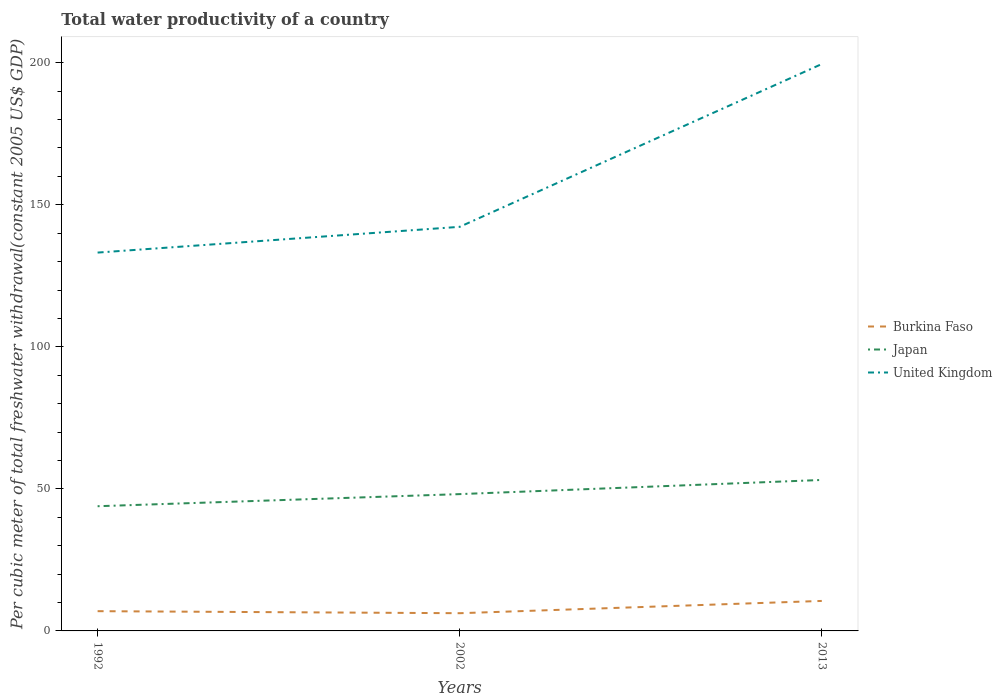Does the line corresponding to United Kingdom intersect with the line corresponding to Burkina Faso?
Give a very brief answer. No. Is the number of lines equal to the number of legend labels?
Your response must be concise. Yes. Across all years, what is the maximum total water productivity in Burkina Faso?
Keep it short and to the point. 6.24. In which year was the total water productivity in United Kingdom maximum?
Your answer should be compact. 1992. What is the total total water productivity in Burkina Faso in the graph?
Provide a short and direct response. -3.6. What is the difference between the highest and the second highest total water productivity in United Kingdom?
Your response must be concise. 66.37. What is the difference between the highest and the lowest total water productivity in Japan?
Offer a terse response. 1. Is the total water productivity in Burkina Faso strictly greater than the total water productivity in United Kingdom over the years?
Your response must be concise. Yes. How many lines are there?
Make the answer very short. 3. Does the graph contain grids?
Offer a very short reply. No. How many legend labels are there?
Your answer should be very brief. 3. What is the title of the graph?
Offer a very short reply. Total water productivity of a country. What is the label or title of the Y-axis?
Keep it short and to the point. Per cubic meter of total freshwater withdrawal(constant 2005 US$ GDP). What is the Per cubic meter of total freshwater withdrawal(constant 2005 US$ GDP) in Burkina Faso in 1992?
Give a very brief answer. 6.95. What is the Per cubic meter of total freshwater withdrawal(constant 2005 US$ GDP) of Japan in 1992?
Your answer should be compact. 43.89. What is the Per cubic meter of total freshwater withdrawal(constant 2005 US$ GDP) in United Kingdom in 1992?
Ensure brevity in your answer.  133.18. What is the Per cubic meter of total freshwater withdrawal(constant 2005 US$ GDP) in Burkina Faso in 2002?
Offer a terse response. 6.24. What is the Per cubic meter of total freshwater withdrawal(constant 2005 US$ GDP) of Japan in 2002?
Offer a very short reply. 48.16. What is the Per cubic meter of total freshwater withdrawal(constant 2005 US$ GDP) of United Kingdom in 2002?
Provide a short and direct response. 142.24. What is the Per cubic meter of total freshwater withdrawal(constant 2005 US$ GDP) of Burkina Faso in 2013?
Your response must be concise. 10.56. What is the Per cubic meter of total freshwater withdrawal(constant 2005 US$ GDP) in Japan in 2013?
Ensure brevity in your answer.  53.14. What is the Per cubic meter of total freshwater withdrawal(constant 2005 US$ GDP) in United Kingdom in 2013?
Ensure brevity in your answer.  199.54. Across all years, what is the maximum Per cubic meter of total freshwater withdrawal(constant 2005 US$ GDP) in Burkina Faso?
Provide a short and direct response. 10.56. Across all years, what is the maximum Per cubic meter of total freshwater withdrawal(constant 2005 US$ GDP) in Japan?
Make the answer very short. 53.14. Across all years, what is the maximum Per cubic meter of total freshwater withdrawal(constant 2005 US$ GDP) in United Kingdom?
Provide a succinct answer. 199.54. Across all years, what is the minimum Per cubic meter of total freshwater withdrawal(constant 2005 US$ GDP) in Burkina Faso?
Provide a short and direct response. 6.24. Across all years, what is the minimum Per cubic meter of total freshwater withdrawal(constant 2005 US$ GDP) of Japan?
Make the answer very short. 43.89. Across all years, what is the minimum Per cubic meter of total freshwater withdrawal(constant 2005 US$ GDP) in United Kingdom?
Keep it short and to the point. 133.18. What is the total Per cubic meter of total freshwater withdrawal(constant 2005 US$ GDP) of Burkina Faso in the graph?
Your response must be concise. 23.75. What is the total Per cubic meter of total freshwater withdrawal(constant 2005 US$ GDP) in Japan in the graph?
Provide a succinct answer. 145.19. What is the total Per cubic meter of total freshwater withdrawal(constant 2005 US$ GDP) in United Kingdom in the graph?
Provide a short and direct response. 474.96. What is the difference between the Per cubic meter of total freshwater withdrawal(constant 2005 US$ GDP) in Burkina Faso in 1992 and that in 2002?
Provide a short and direct response. 0.72. What is the difference between the Per cubic meter of total freshwater withdrawal(constant 2005 US$ GDP) in Japan in 1992 and that in 2002?
Give a very brief answer. -4.26. What is the difference between the Per cubic meter of total freshwater withdrawal(constant 2005 US$ GDP) of United Kingdom in 1992 and that in 2002?
Your response must be concise. -9.07. What is the difference between the Per cubic meter of total freshwater withdrawal(constant 2005 US$ GDP) of Burkina Faso in 1992 and that in 2013?
Provide a succinct answer. -3.6. What is the difference between the Per cubic meter of total freshwater withdrawal(constant 2005 US$ GDP) of Japan in 1992 and that in 2013?
Your response must be concise. -9.24. What is the difference between the Per cubic meter of total freshwater withdrawal(constant 2005 US$ GDP) of United Kingdom in 1992 and that in 2013?
Provide a short and direct response. -66.37. What is the difference between the Per cubic meter of total freshwater withdrawal(constant 2005 US$ GDP) of Burkina Faso in 2002 and that in 2013?
Provide a succinct answer. -4.32. What is the difference between the Per cubic meter of total freshwater withdrawal(constant 2005 US$ GDP) in Japan in 2002 and that in 2013?
Make the answer very short. -4.98. What is the difference between the Per cubic meter of total freshwater withdrawal(constant 2005 US$ GDP) in United Kingdom in 2002 and that in 2013?
Provide a succinct answer. -57.3. What is the difference between the Per cubic meter of total freshwater withdrawal(constant 2005 US$ GDP) of Burkina Faso in 1992 and the Per cubic meter of total freshwater withdrawal(constant 2005 US$ GDP) of Japan in 2002?
Provide a succinct answer. -41.2. What is the difference between the Per cubic meter of total freshwater withdrawal(constant 2005 US$ GDP) of Burkina Faso in 1992 and the Per cubic meter of total freshwater withdrawal(constant 2005 US$ GDP) of United Kingdom in 2002?
Keep it short and to the point. -135.29. What is the difference between the Per cubic meter of total freshwater withdrawal(constant 2005 US$ GDP) in Japan in 1992 and the Per cubic meter of total freshwater withdrawal(constant 2005 US$ GDP) in United Kingdom in 2002?
Ensure brevity in your answer.  -98.35. What is the difference between the Per cubic meter of total freshwater withdrawal(constant 2005 US$ GDP) of Burkina Faso in 1992 and the Per cubic meter of total freshwater withdrawal(constant 2005 US$ GDP) of Japan in 2013?
Your response must be concise. -46.19. What is the difference between the Per cubic meter of total freshwater withdrawal(constant 2005 US$ GDP) in Burkina Faso in 1992 and the Per cubic meter of total freshwater withdrawal(constant 2005 US$ GDP) in United Kingdom in 2013?
Keep it short and to the point. -192.59. What is the difference between the Per cubic meter of total freshwater withdrawal(constant 2005 US$ GDP) of Japan in 1992 and the Per cubic meter of total freshwater withdrawal(constant 2005 US$ GDP) of United Kingdom in 2013?
Make the answer very short. -155.65. What is the difference between the Per cubic meter of total freshwater withdrawal(constant 2005 US$ GDP) of Burkina Faso in 2002 and the Per cubic meter of total freshwater withdrawal(constant 2005 US$ GDP) of Japan in 2013?
Provide a succinct answer. -46.9. What is the difference between the Per cubic meter of total freshwater withdrawal(constant 2005 US$ GDP) in Burkina Faso in 2002 and the Per cubic meter of total freshwater withdrawal(constant 2005 US$ GDP) in United Kingdom in 2013?
Make the answer very short. -193.31. What is the difference between the Per cubic meter of total freshwater withdrawal(constant 2005 US$ GDP) of Japan in 2002 and the Per cubic meter of total freshwater withdrawal(constant 2005 US$ GDP) of United Kingdom in 2013?
Make the answer very short. -151.39. What is the average Per cubic meter of total freshwater withdrawal(constant 2005 US$ GDP) of Burkina Faso per year?
Keep it short and to the point. 7.92. What is the average Per cubic meter of total freshwater withdrawal(constant 2005 US$ GDP) in Japan per year?
Your answer should be very brief. 48.4. What is the average Per cubic meter of total freshwater withdrawal(constant 2005 US$ GDP) of United Kingdom per year?
Give a very brief answer. 158.32. In the year 1992, what is the difference between the Per cubic meter of total freshwater withdrawal(constant 2005 US$ GDP) of Burkina Faso and Per cubic meter of total freshwater withdrawal(constant 2005 US$ GDP) of Japan?
Provide a short and direct response. -36.94. In the year 1992, what is the difference between the Per cubic meter of total freshwater withdrawal(constant 2005 US$ GDP) in Burkina Faso and Per cubic meter of total freshwater withdrawal(constant 2005 US$ GDP) in United Kingdom?
Give a very brief answer. -126.22. In the year 1992, what is the difference between the Per cubic meter of total freshwater withdrawal(constant 2005 US$ GDP) in Japan and Per cubic meter of total freshwater withdrawal(constant 2005 US$ GDP) in United Kingdom?
Keep it short and to the point. -89.28. In the year 2002, what is the difference between the Per cubic meter of total freshwater withdrawal(constant 2005 US$ GDP) of Burkina Faso and Per cubic meter of total freshwater withdrawal(constant 2005 US$ GDP) of Japan?
Your answer should be very brief. -41.92. In the year 2002, what is the difference between the Per cubic meter of total freshwater withdrawal(constant 2005 US$ GDP) in Burkina Faso and Per cubic meter of total freshwater withdrawal(constant 2005 US$ GDP) in United Kingdom?
Provide a short and direct response. -136.01. In the year 2002, what is the difference between the Per cubic meter of total freshwater withdrawal(constant 2005 US$ GDP) of Japan and Per cubic meter of total freshwater withdrawal(constant 2005 US$ GDP) of United Kingdom?
Give a very brief answer. -94.09. In the year 2013, what is the difference between the Per cubic meter of total freshwater withdrawal(constant 2005 US$ GDP) in Burkina Faso and Per cubic meter of total freshwater withdrawal(constant 2005 US$ GDP) in Japan?
Give a very brief answer. -42.58. In the year 2013, what is the difference between the Per cubic meter of total freshwater withdrawal(constant 2005 US$ GDP) of Burkina Faso and Per cubic meter of total freshwater withdrawal(constant 2005 US$ GDP) of United Kingdom?
Provide a short and direct response. -188.99. In the year 2013, what is the difference between the Per cubic meter of total freshwater withdrawal(constant 2005 US$ GDP) of Japan and Per cubic meter of total freshwater withdrawal(constant 2005 US$ GDP) of United Kingdom?
Ensure brevity in your answer.  -146.41. What is the ratio of the Per cubic meter of total freshwater withdrawal(constant 2005 US$ GDP) of Burkina Faso in 1992 to that in 2002?
Offer a very short reply. 1.11. What is the ratio of the Per cubic meter of total freshwater withdrawal(constant 2005 US$ GDP) of Japan in 1992 to that in 2002?
Give a very brief answer. 0.91. What is the ratio of the Per cubic meter of total freshwater withdrawal(constant 2005 US$ GDP) of United Kingdom in 1992 to that in 2002?
Your response must be concise. 0.94. What is the ratio of the Per cubic meter of total freshwater withdrawal(constant 2005 US$ GDP) of Burkina Faso in 1992 to that in 2013?
Give a very brief answer. 0.66. What is the ratio of the Per cubic meter of total freshwater withdrawal(constant 2005 US$ GDP) of Japan in 1992 to that in 2013?
Keep it short and to the point. 0.83. What is the ratio of the Per cubic meter of total freshwater withdrawal(constant 2005 US$ GDP) of United Kingdom in 1992 to that in 2013?
Provide a succinct answer. 0.67. What is the ratio of the Per cubic meter of total freshwater withdrawal(constant 2005 US$ GDP) of Burkina Faso in 2002 to that in 2013?
Ensure brevity in your answer.  0.59. What is the ratio of the Per cubic meter of total freshwater withdrawal(constant 2005 US$ GDP) in Japan in 2002 to that in 2013?
Ensure brevity in your answer.  0.91. What is the ratio of the Per cubic meter of total freshwater withdrawal(constant 2005 US$ GDP) in United Kingdom in 2002 to that in 2013?
Provide a short and direct response. 0.71. What is the difference between the highest and the second highest Per cubic meter of total freshwater withdrawal(constant 2005 US$ GDP) of Burkina Faso?
Offer a very short reply. 3.6. What is the difference between the highest and the second highest Per cubic meter of total freshwater withdrawal(constant 2005 US$ GDP) in Japan?
Ensure brevity in your answer.  4.98. What is the difference between the highest and the second highest Per cubic meter of total freshwater withdrawal(constant 2005 US$ GDP) in United Kingdom?
Provide a succinct answer. 57.3. What is the difference between the highest and the lowest Per cubic meter of total freshwater withdrawal(constant 2005 US$ GDP) of Burkina Faso?
Give a very brief answer. 4.32. What is the difference between the highest and the lowest Per cubic meter of total freshwater withdrawal(constant 2005 US$ GDP) in Japan?
Your answer should be compact. 9.24. What is the difference between the highest and the lowest Per cubic meter of total freshwater withdrawal(constant 2005 US$ GDP) in United Kingdom?
Give a very brief answer. 66.37. 